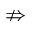<formula> <loc_0><loc_0><loc_500><loc_500>\ n R i g h t a r r o w</formula> 